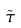<formula> <loc_0><loc_0><loc_500><loc_500>\tilde { \tau }</formula> 